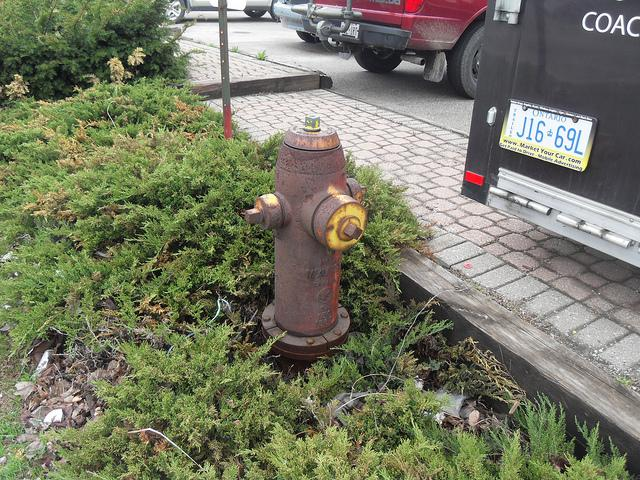Where is the fire hydrant mounted?

Choices:
A) tree
B) landscape
C) sidewalk
D) parking lot landscape 